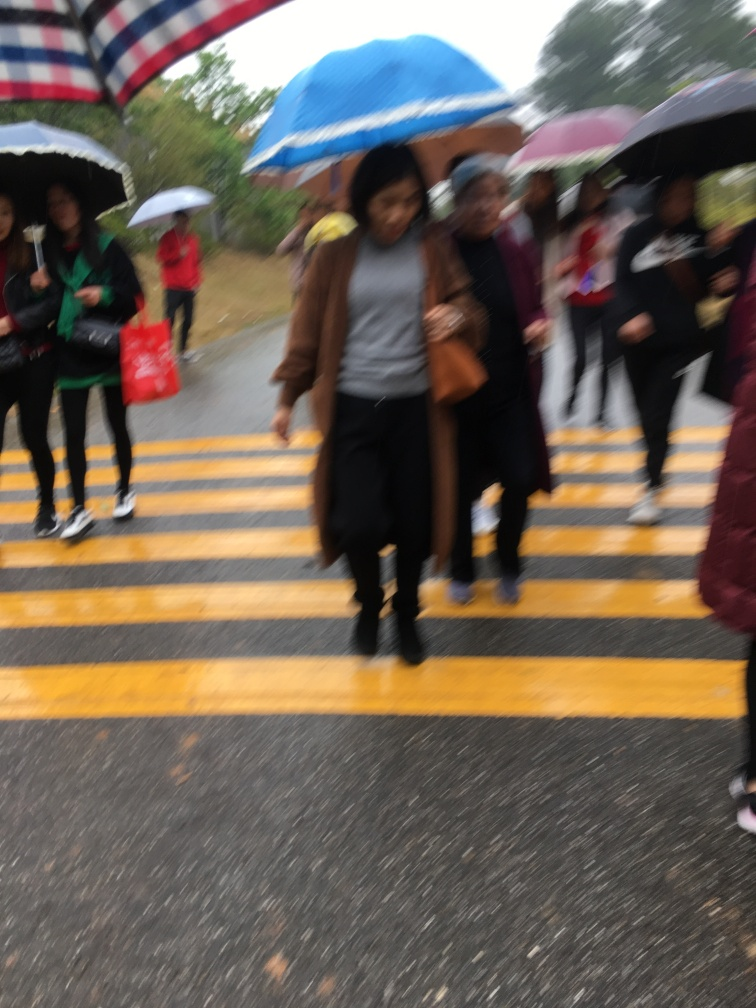Describe the setting captured in this image. The image captures a group of people, some with umbrellas, crossing the street at a pedestrian crossing, which implies an urban or suburban setting. The presence of umbrellas and the overcast ambiance indicate it might be a rainy day. Is there anything unique about their attire or the situation? Nothing particularly unique stands out about their attire; it seems quite typical for a rainy day, with most people dressed in practical, casual wear suitable for wet weather. The situation is typical of a busy pedestrian crossing. 